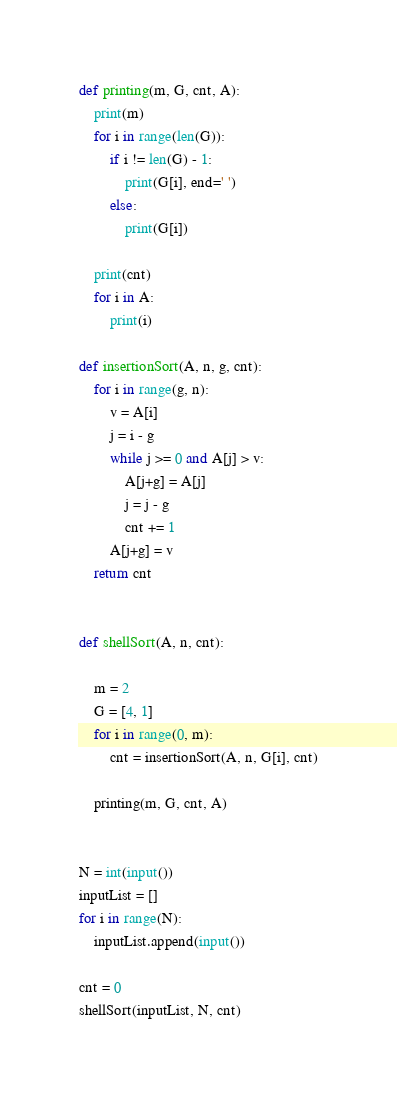Convert code to text. <code><loc_0><loc_0><loc_500><loc_500><_Python_>def printing(m, G, cnt, A):
    print(m)
    for i in range(len(G)):
        if i != len(G) - 1:
            print(G[i], end=' ')
        else:
            print(G[i])

    print(cnt)
    for i in A:
        print(i)

def insertionSort(A, n, g, cnt):
    for i in range(g, n):
        v = A[i]
        j = i - g
        while j >= 0 and A[j] > v:
            A[j+g] = A[j]
            j = j - g
            cnt += 1
        A[j+g] = v
    return cnt


def shellSort(A, n, cnt):

    m = 2
    G = [4, 1]
    for i in range(0, m):
        cnt = insertionSort(A, n, G[i], cnt)

    printing(m, G, cnt, A)


N = int(input())
inputList = []
for i in range(N):
    inputList.append(input())

cnt = 0
shellSort(inputList, N, cnt)
</code> 